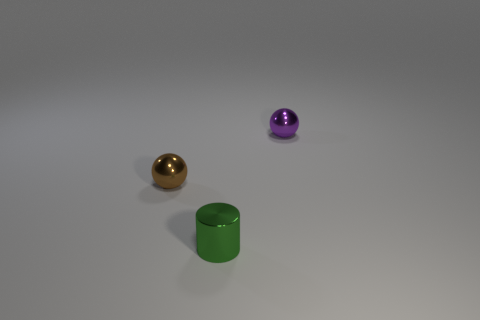The small cylinder is what color?
Keep it short and to the point. Green. What number of other objects are there of the same size as the green object?
Your answer should be very brief. 2. What material is the thing that is on the left side of the tiny purple shiny object and behind the tiny green shiny cylinder?
Make the answer very short. Metal. Does the brown ball left of the purple metal sphere have the same size as the purple sphere?
Offer a very short reply. Yes. What number of small shiny things are in front of the brown metallic object and behind the green thing?
Provide a short and direct response. 0. There is a sphere behind the small metal sphere on the left side of the purple thing; what number of metal things are behind it?
Make the answer very short. 0. What is the shape of the green object?
Keep it short and to the point. Cylinder. How many tiny green cubes are the same material as the tiny purple thing?
Your response must be concise. 0. There is a tiny cylinder that is the same material as the purple ball; what is its color?
Offer a terse response. Green. There is a purple ball; does it have the same size as the metallic ball that is on the left side of the small purple sphere?
Your answer should be very brief. Yes. 